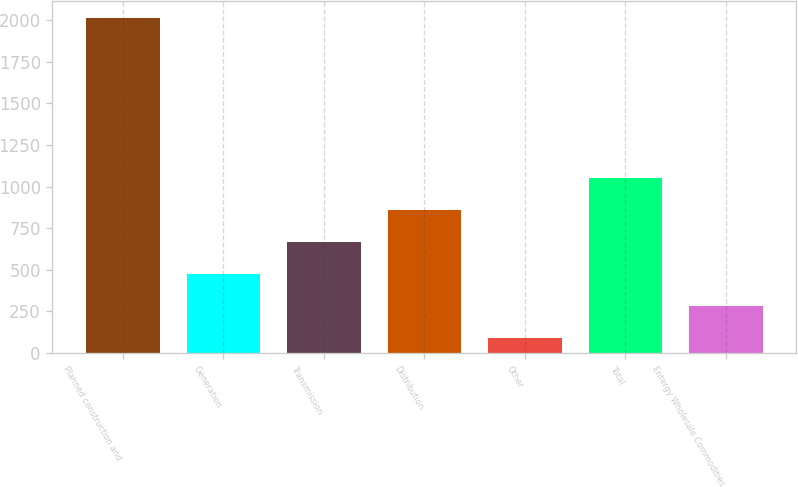Convert chart to OTSL. <chart><loc_0><loc_0><loc_500><loc_500><bar_chart><fcel>Planned construction and<fcel>Generation<fcel>Transmission<fcel>Distribution<fcel>Other<fcel>Total<fcel>Entergy Wholesale Commodities<nl><fcel>2013<fcel>473.8<fcel>666.2<fcel>858.6<fcel>89<fcel>1051<fcel>281.4<nl></chart> 